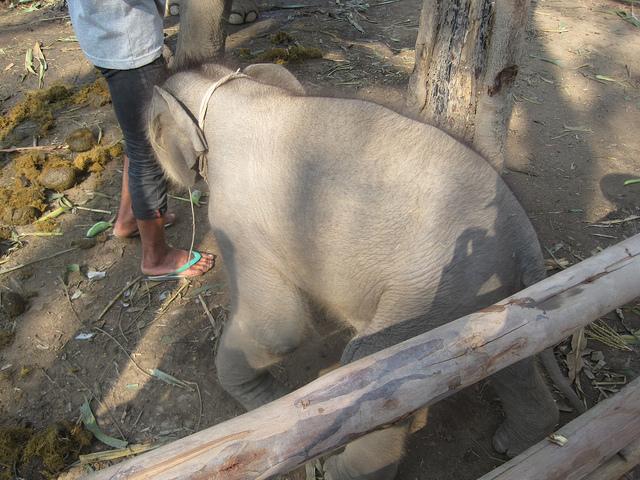What is the creature on top of the animal?
Short answer required. Elephant. What kind of animal is in the picture?
Answer briefly. Elephant. How tall is the elephant?
Keep it brief. 2 feet. What color flip flops are shown?
Quick response, please. Blue. 